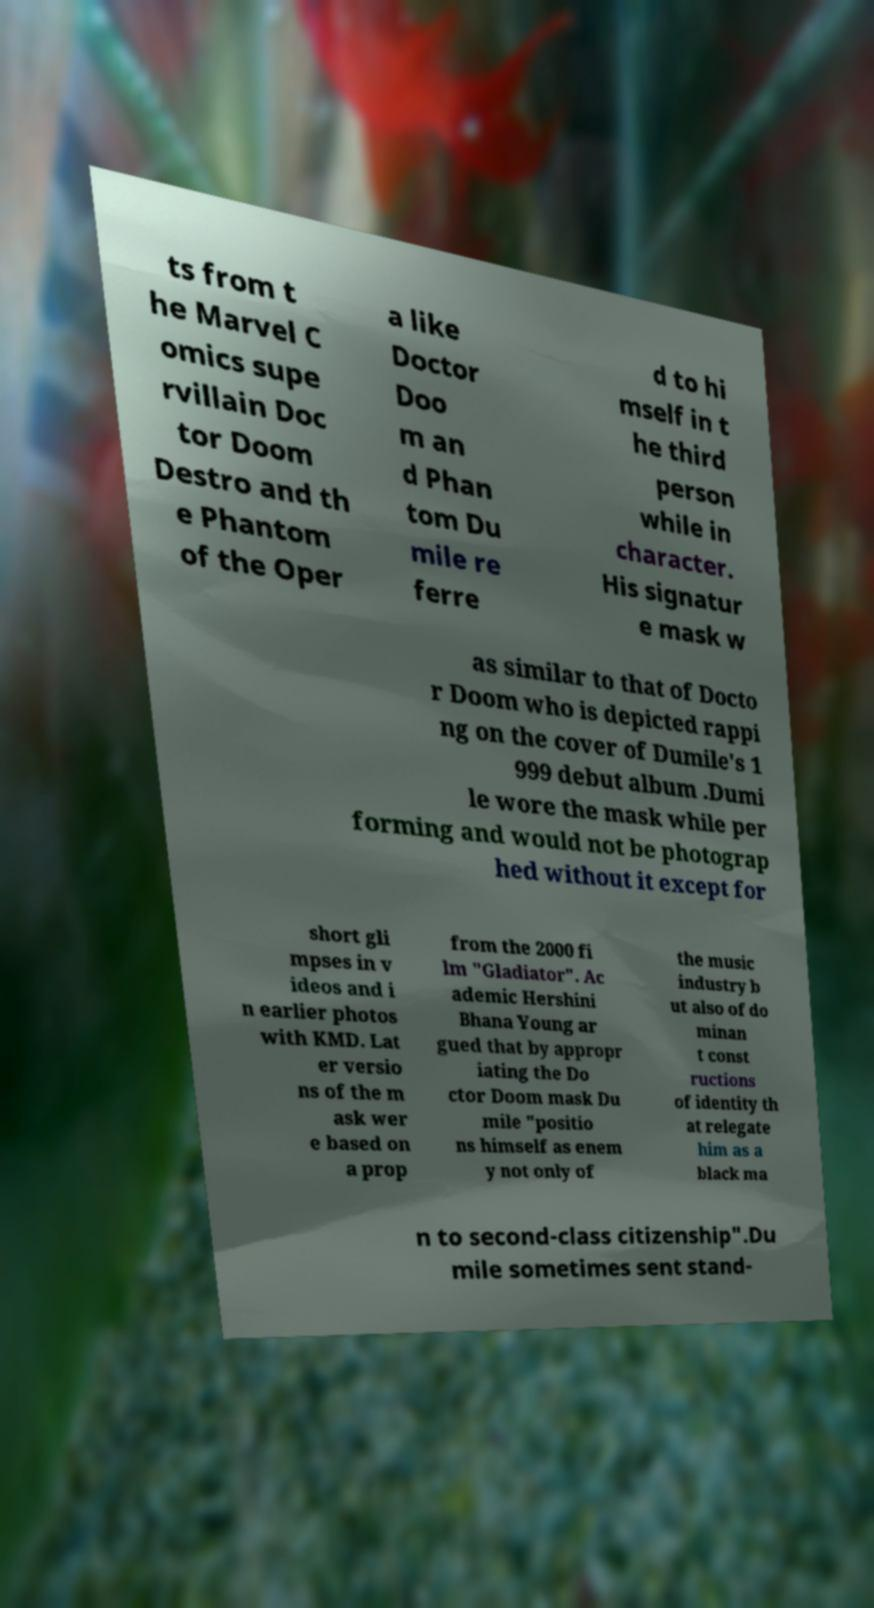For documentation purposes, I need the text within this image transcribed. Could you provide that? ts from t he Marvel C omics supe rvillain Doc tor Doom Destro and th e Phantom of the Oper a like Doctor Doo m an d Phan tom Du mile re ferre d to hi mself in t he third person while in character. His signatur e mask w as similar to that of Docto r Doom who is depicted rappi ng on the cover of Dumile's 1 999 debut album .Dumi le wore the mask while per forming and would not be photograp hed without it except for short gli mpses in v ideos and i n earlier photos with KMD. Lat er versio ns of the m ask wer e based on a prop from the 2000 fi lm "Gladiator". Ac ademic Hershini Bhana Young ar gued that by appropr iating the Do ctor Doom mask Du mile "positio ns himself as enem y not only of the music industry b ut also of do minan t const ructions of identity th at relegate him as a black ma n to second-class citizenship".Du mile sometimes sent stand- 